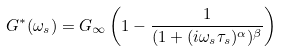<formula> <loc_0><loc_0><loc_500><loc_500>G ^ { \ast } ( \omega _ { s } ) = G _ { \infty } \left ( 1 - \frac { 1 } { ( 1 + ( i \omega _ { s } \tau _ { s } ) ^ { \alpha } ) ^ { \beta } } \right )</formula> 